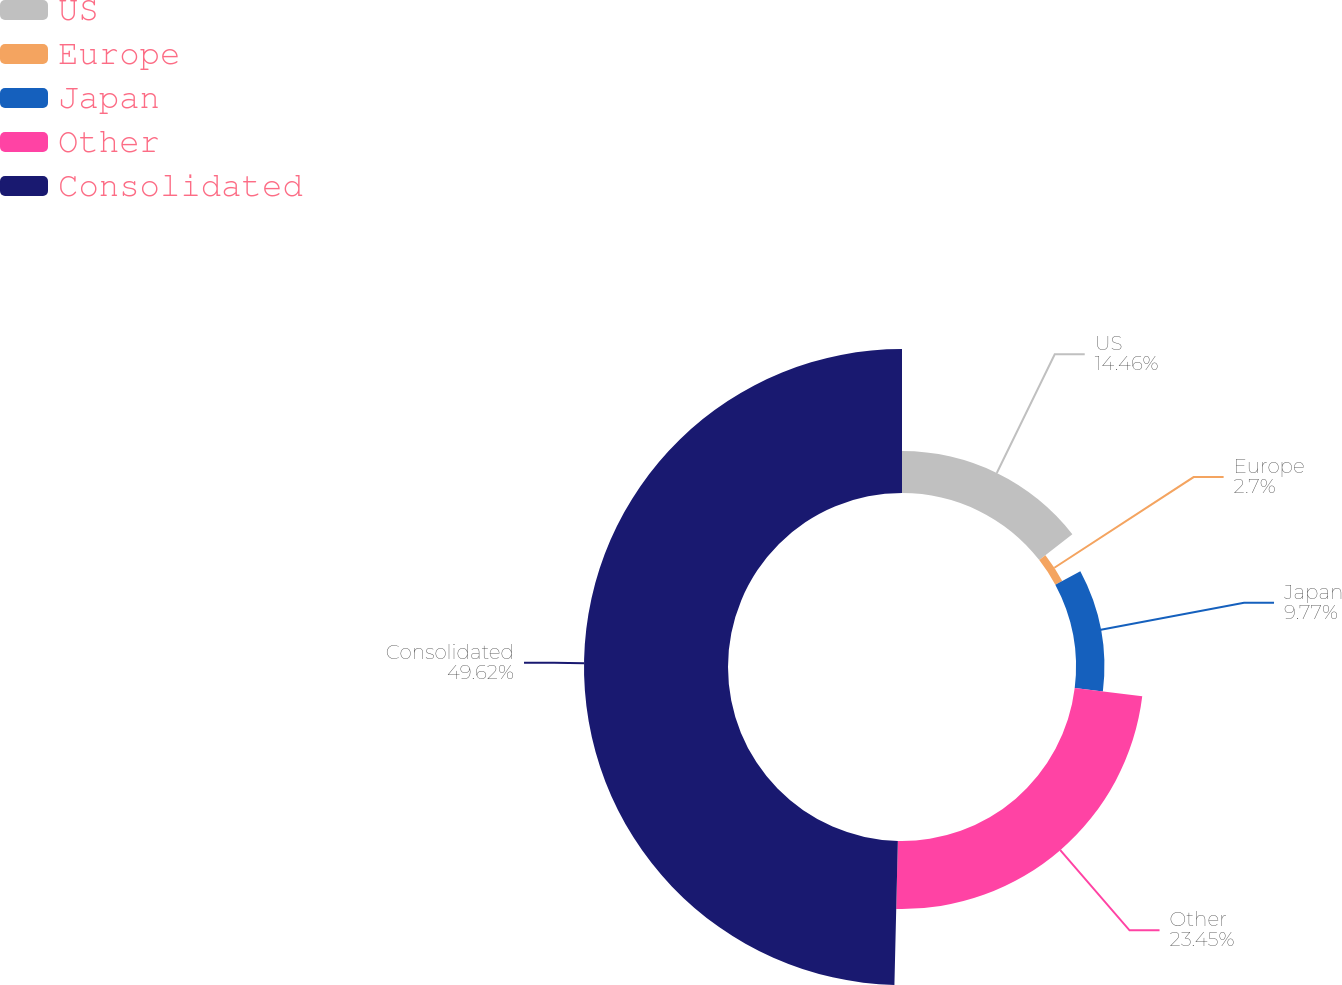<chart> <loc_0><loc_0><loc_500><loc_500><pie_chart><fcel>US<fcel>Europe<fcel>Japan<fcel>Other<fcel>Consolidated<nl><fcel>14.46%<fcel>2.7%<fcel>9.77%<fcel>23.44%<fcel>49.61%<nl></chart> 